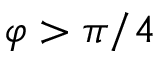<formula> <loc_0><loc_0><loc_500><loc_500>\varphi > \pi / 4</formula> 